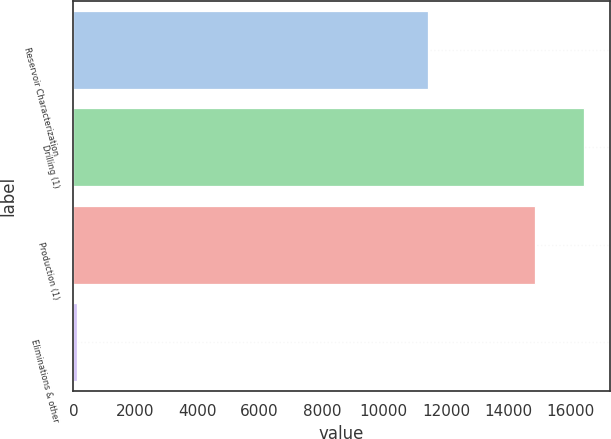<chart> <loc_0><loc_0><loc_500><loc_500><bar_chart><fcel>Reservoir Characterization<fcel>Drilling (1)<fcel>Production (1)<fcel>Eliminations & other<nl><fcel>11424<fcel>16460<fcel>14875<fcel>121<nl></chart> 